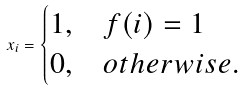Convert formula to latex. <formula><loc_0><loc_0><loc_500><loc_500>x _ { i } = \begin{cases} 1 , & f ( i ) = 1 \\ 0 , & o t h e r w i s e . \end{cases}</formula> 